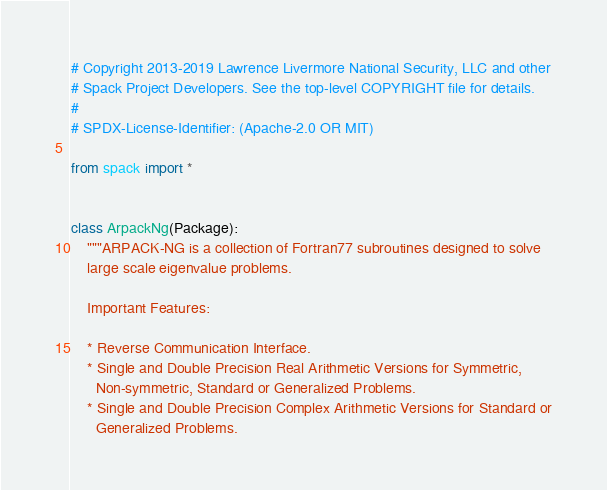Convert code to text. <code><loc_0><loc_0><loc_500><loc_500><_Python_># Copyright 2013-2019 Lawrence Livermore National Security, LLC and other
# Spack Project Developers. See the top-level COPYRIGHT file for details.
#
# SPDX-License-Identifier: (Apache-2.0 OR MIT)

from spack import *


class ArpackNg(Package):
    """ARPACK-NG is a collection of Fortran77 subroutines designed to solve
    large scale eigenvalue problems.

    Important Features:

    * Reverse Communication Interface.
    * Single and Double Precision Real Arithmetic Versions for Symmetric,
      Non-symmetric, Standard or Generalized Problems.
    * Single and Double Precision Complex Arithmetic Versions for Standard or
      Generalized Problems.</code> 